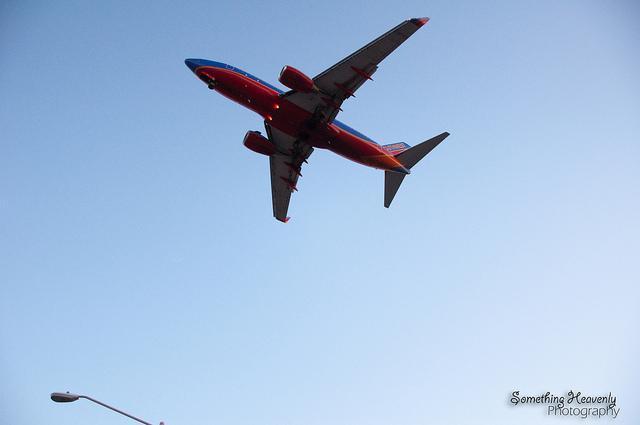How many different colors is this airplane?
Give a very brief answer. 3. How many airplane doors are visible?
Give a very brief answer. 0. 